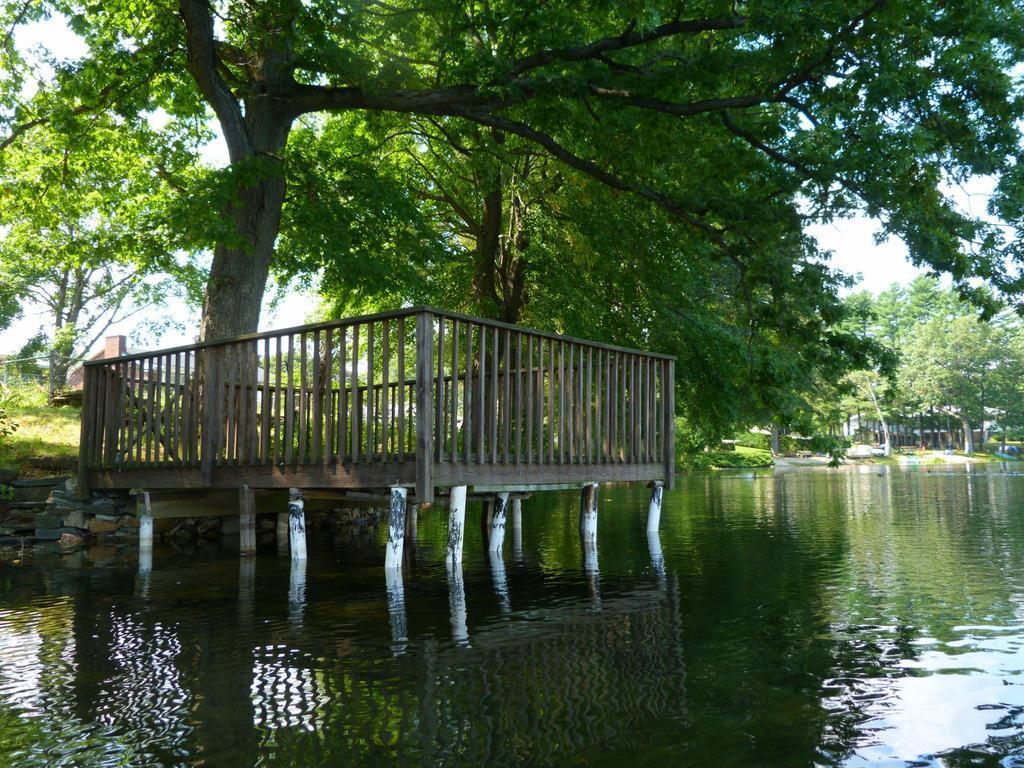How would you summarize this image in a sentence or two? In this image there is the water. To the left there is a dock on the water. There is a wooden railing around the dock. In the background there are trees and houses. At the top there is the sky. There is grass on the ground. 